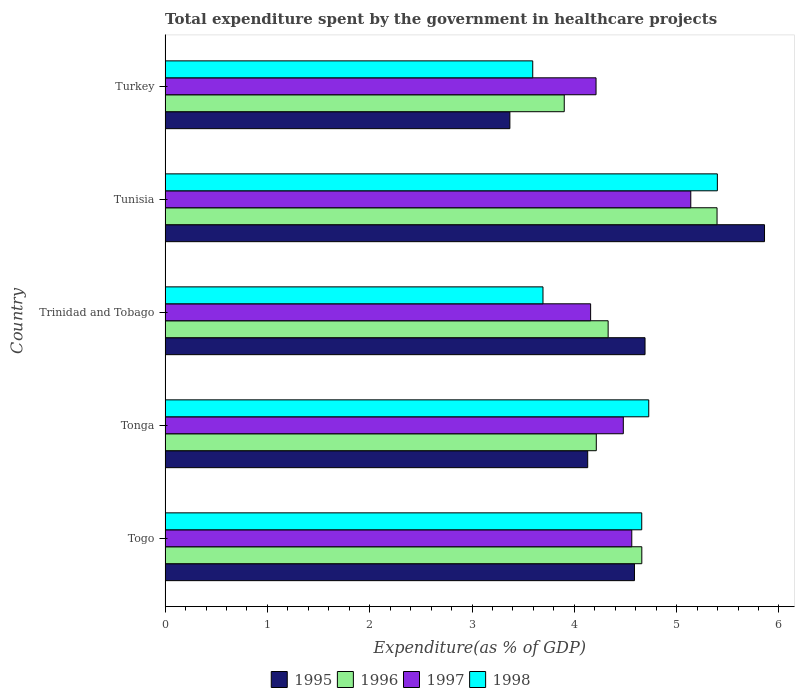How many groups of bars are there?
Your answer should be very brief. 5. Are the number of bars per tick equal to the number of legend labels?
Your answer should be very brief. Yes. What is the label of the 4th group of bars from the top?
Provide a short and direct response. Tonga. In how many cases, is the number of bars for a given country not equal to the number of legend labels?
Offer a terse response. 0. What is the total expenditure spent by the government in healthcare projects in 1996 in Tonga?
Make the answer very short. 4.21. Across all countries, what is the maximum total expenditure spent by the government in healthcare projects in 1995?
Offer a very short reply. 5.86. Across all countries, what is the minimum total expenditure spent by the government in healthcare projects in 1998?
Give a very brief answer. 3.59. In which country was the total expenditure spent by the government in healthcare projects in 1998 maximum?
Give a very brief answer. Tunisia. What is the total total expenditure spent by the government in healthcare projects in 1998 in the graph?
Provide a succinct answer. 22.07. What is the difference between the total expenditure spent by the government in healthcare projects in 1998 in Togo and that in Turkey?
Keep it short and to the point. 1.07. What is the difference between the total expenditure spent by the government in healthcare projects in 1995 in Tunisia and the total expenditure spent by the government in healthcare projects in 1998 in Trinidad and Tobago?
Keep it short and to the point. 2.17. What is the average total expenditure spent by the government in healthcare projects in 1995 per country?
Provide a succinct answer. 4.53. What is the difference between the total expenditure spent by the government in healthcare projects in 1996 and total expenditure spent by the government in healthcare projects in 1998 in Trinidad and Tobago?
Keep it short and to the point. 0.64. What is the ratio of the total expenditure spent by the government in healthcare projects in 1997 in Tonga to that in Turkey?
Your answer should be compact. 1.06. What is the difference between the highest and the second highest total expenditure spent by the government in healthcare projects in 1995?
Give a very brief answer. 1.17. What is the difference between the highest and the lowest total expenditure spent by the government in healthcare projects in 1997?
Offer a very short reply. 0.98. Is the sum of the total expenditure spent by the government in healthcare projects in 1995 in Tonga and Turkey greater than the maximum total expenditure spent by the government in healthcare projects in 1997 across all countries?
Provide a succinct answer. Yes. Is it the case that in every country, the sum of the total expenditure spent by the government in healthcare projects in 1998 and total expenditure spent by the government in healthcare projects in 1996 is greater than the sum of total expenditure spent by the government in healthcare projects in 1995 and total expenditure spent by the government in healthcare projects in 1997?
Offer a terse response. No. What does the 1st bar from the top in Togo represents?
Your response must be concise. 1998. Is it the case that in every country, the sum of the total expenditure spent by the government in healthcare projects in 1997 and total expenditure spent by the government in healthcare projects in 1996 is greater than the total expenditure spent by the government in healthcare projects in 1995?
Ensure brevity in your answer.  Yes. How many bars are there?
Offer a terse response. 20. Are all the bars in the graph horizontal?
Your response must be concise. Yes. Where does the legend appear in the graph?
Provide a short and direct response. Bottom center. How many legend labels are there?
Your response must be concise. 4. What is the title of the graph?
Your answer should be very brief. Total expenditure spent by the government in healthcare projects. Does "2003" appear as one of the legend labels in the graph?
Provide a short and direct response. No. What is the label or title of the X-axis?
Offer a terse response. Expenditure(as % of GDP). What is the label or title of the Y-axis?
Your answer should be very brief. Country. What is the Expenditure(as % of GDP) in 1995 in Togo?
Keep it short and to the point. 4.59. What is the Expenditure(as % of GDP) in 1996 in Togo?
Provide a short and direct response. 4.66. What is the Expenditure(as % of GDP) of 1997 in Togo?
Your answer should be very brief. 4.56. What is the Expenditure(as % of GDP) of 1998 in Togo?
Offer a terse response. 4.66. What is the Expenditure(as % of GDP) in 1995 in Tonga?
Ensure brevity in your answer.  4.13. What is the Expenditure(as % of GDP) in 1996 in Tonga?
Make the answer very short. 4.21. What is the Expenditure(as % of GDP) in 1997 in Tonga?
Provide a succinct answer. 4.48. What is the Expenditure(as % of GDP) of 1998 in Tonga?
Make the answer very short. 4.73. What is the Expenditure(as % of GDP) in 1995 in Trinidad and Tobago?
Give a very brief answer. 4.69. What is the Expenditure(as % of GDP) of 1996 in Trinidad and Tobago?
Offer a terse response. 4.33. What is the Expenditure(as % of GDP) of 1997 in Trinidad and Tobago?
Your response must be concise. 4.16. What is the Expenditure(as % of GDP) of 1998 in Trinidad and Tobago?
Make the answer very short. 3.69. What is the Expenditure(as % of GDP) of 1995 in Tunisia?
Keep it short and to the point. 5.86. What is the Expenditure(as % of GDP) in 1996 in Tunisia?
Offer a terse response. 5.4. What is the Expenditure(as % of GDP) of 1997 in Tunisia?
Offer a terse response. 5.14. What is the Expenditure(as % of GDP) in 1998 in Tunisia?
Provide a short and direct response. 5.4. What is the Expenditure(as % of GDP) of 1995 in Turkey?
Make the answer very short. 3.37. What is the Expenditure(as % of GDP) in 1996 in Turkey?
Your answer should be very brief. 3.9. What is the Expenditure(as % of GDP) in 1997 in Turkey?
Ensure brevity in your answer.  4.21. What is the Expenditure(as % of GDP) of 1998 in Turkey?
Provide a short and direct response. 3.59. Across all countries, what is the maximum Expenditure(as % of GDP) in 1995?
Your answer should be compact. 5.86. Across all countries, what is the maximum Expenditure(as % of GDP) of 1996?
Provide a short and direct response. 5.4. Across all countries, what is the maximum Expenditure(as % of GDP) in 1997?
Offer a terse response. 5.14. Across all countries, what is the maximum Expenditure(as % of GDP) in 1998?
Provide a succinct answer. 5.4. Across all countries, what is the minimum Expenditure(as % of GDP) of 1995?
Offer a terse response. 3.37. Across all countries, what is the minimum Expenditure(as % of GDP) of 1996?
Provide a succinct answer. 3.9. Across all countries, what is the minimum Expenditure(as % of GDP) in 1997?
Provide a succinct answer. 4.16. Across all countries, what is the minimum Expenditure(as % of GDP) of 1998?
Provide a succinct answer. 3.59. What is the total Expenditure(as % of GDP) in 1995 in the graph?
Your answer should be compact. 22.64. What is the total Expenditure(as % of GDP) of 1996 in the graph?
Your answer should be very brief. 22.5. What is the total Expenditure(as % of GDP) of 1997 in the graph?
Your answer should be very brief. 22.55. What is the total Expenditure(as % of GDP) of 1998 in the graph?
Your response must be concise. 22.07. What is the difference between the Expenditure(as % of GDP) of 1995 in Togo and that in Tonga?
Offer a very short reply. 0.46. What is the difference between the Expenditure(as % of GDP) in 1996 in Togo and that in Tonga?
Make the answer very short. 0.44. What is the difference between the Expenditure(as % of GDP) of 1997 in Togo and that in Tonga?
Ensure brevity in your answer.  0.08. What is the difference between the Expenditure(as % of GDP) of 1998 in Togo and that in Tonga?
Keep it short and to the point. -0.07. What is the difference between the Expenditure(as % of GDP) of 1995 in Togo and that in Trinidad and Tobago?
Offer a terse response. -0.1. What is the difference between the Expenditure(as % of GDP) of 1996 in Togo and that in Trinidad and Tobago?
Your answer should be very brief. 0.33. What is the difference between the Expenditure(as % of GDP) in 1997 in Togo and that in Trinidad and Tobago?
Your response must be concise. 0.4. What is the difference between the Expenditure(as % of GDP) of 1998 in Togo and that in Trinidad and Tobago?
Offer a very short reply. 0.97. What is the difference between the Expenditure(as % of GDP) of 1995 in Togo and that in Tunisia?
Offer a very short reply. -1.27. What is the difference between the Expenditure(as % of GDP) of 1996 in Togo and that in Tunisia?
Your answer should be compact. -0.74. What is the difference between the Expenditure(as % of GDP) of 1997 in Togo and that in Tunisia?
Make the answer very short. -0.58. What is the difference between the Expenditure(as % of GDP) in 1998 in Togo and that in Tunisia?
Your answer should be very brief. -0.74. What is the difference between the Expenditure(as % of GDP) of 1995 in Togo and that in Turkey?
Give a very brief answer. 1.22. What is the difference between the Expenditure(as % of GDP) of 1996 in Togo and that in Turkey?
Make the answer very short. 0.76. What is the difference between the Expenditure(as % of GDP) of 1997 in Togo and that in Turkey?
Provide a succinct answer. 0.35. What is the difference between the Expenditure(as % of GDP) of 1998 in Togo and that in Turkey?
Give a very brief answer. 1.07. What is the difference between the Expenditure(as % of GDP) of 1995 in Tonga and that in Trinidad and Tobago?
Offer a very short reply. -0.56. What is the difference between the Expenditure(as % of GDP) in 1996 in Tonga and that in Trinidad and Tobago?
Your response must be concise. -0.12. What is the difference between the Expenditure(as % of GDP) in 1997 in Tonga and that in Trinidad and Tobago?
Provide a succinct answer. 0.32. What is the difference between the Expenditure(as % of GDP) in 1998 in Tonga and that in Trinidad and Tobago?
Offer a terse response. 1.03. What is the difference between the Expenditure(as % of GDP) of 1995 in Tonga and that in Tunisia?
Your answer should be very brief. -1.73. What is the difference between the Expenditure(as % of GDP) in 1996 in Tonga and that in Tunisia?
Keep it short and to the point. -1.18. What is the difference between the Expenditure(as % of GDP) in 1997 in Tonga and that in Tunisia?
Your response must be concise. -0.66. What is the difference between the Expenditure(as % of GDP) of 1998 in Tonga and that in Tunisia?
Make the answer very short. -0.67. What is the difference between the Expenditure(as % of GDP) of 1995 in Tonga and that in Turkey?
Give a very brief answer. 0.76. What is the difference between the Expenditure(as % of GDP) of 1996 in Tonga and that in Turkey?
Ensure brevity in your answer.  0.31. What is the difference between the Expenditure(as % of GDP) in 1997 in Tonga and that in Turkey?
Your answer should be compact. 0.27. What is the difference between the Expenditure(as % of GDP) of 1998 in Tonga and that in Turkey?
Keep it short and to the point. 1.13. What is the difference between the Expenditure(as % of GDP) of 1995 in Trinidad and Tobago and that in Tunisia?
Your answer should be very brief. -1.17. What is the difference between the Expenditure(as % of GDP) in 1996 in Trinidad and Tobago and that in Tunisia?
Offer a terse response. -1.06. What is the difference between the Expenditure(as % of GDP) in 1997 in Trinidad and Tobago and that in Tunisia?
Provide a short and direct response. -0.98. What is the difference between the Expenditure(as % of GDP) of 1998 in Trinidad and Tobago and that in Tunisia?
Provide a short and direct response. -1.7. What is the difference between the Expenditure(as % of GDP) in 1995 in Trinidad and Tobago and that in Turkey?
Give a very brief answer. 1.32. What is the difference between the Expenditure(as % of GDP) in 1996 in Trinidad and Tobago and that in Turkey?
Offer a very short reply. 0.43. What is the difference between the Expenditure(as % of GDP) of 1997 in Trinidad and Tobago and that in Turkey?
Give a very brief answer. -0.05. What is the difference between the Expenditure(as % of GDP) in 1998 in Trinidad and Tobago and that in Turkey?
Provide a short and direct response. 0.1. What is the difference between the Expenditure(as % of GDP) in 1995 in Tunisia and that in Turkey?
Your answer should be very brief. 2.49. What is the difference between the Expenditure(as % of GDP) in 1996 in Tunisia and that in Turkey?
Ensure brevity in your answer.  1.49. What is the difference between the Expenditure(as % of GDP) in 1997 in Tunisia and that in Turkey?
Give a very brief answer. 0.93. What is the difference between the Expenditure(as % of GDP) of 1998 in Tunisia and that in Turkey?
Provide a short and direct response. 1.8. What is the difference between the Expenditure(as % of GDP) in 1995 in Togo and the Expenditure(as % of GDP) in 1996 in Tonga?
Your response must be concise. 0.37. What is the difference between the Expenditure(as % of GDP) in 1995 in Togo and the Expenditure(as % of GDP) in 1997 in Tonga?
Ensure brevity in your answer.  0.11. What is the difference between the Expenditure(as % of GDP) of 1995 in Togo and the Expenditure(as % of GDP) of 1998 in Tonga?
Your answer should be compact. -0.14. What is the difference between the Expenditure(as % of GDP) of 1996 in Togo and the Expenditure(as % of GDP) of 1997 in Tonga?
Keep it short and to the point. 0.18. What is the difference between the Expenditure(as % of GDP) of 1996 in Togo and the Expenditure(as % of GDP) of 1998 in Tonga?
Keep it short and to the point. -0.07. What is the difference between the Expenditure(as % of GDP) in 1997 in Togo and the Expenditure(as % of GDP) in 1998 in Tonga?
Offer a very short reply. -0.17. What is the difference between the Expenditure(as % of GDP) of 1995 in Togo and the Expenditure(as % of GDP) of 1996 in Trinidad and Tobago?
Your answer should be very brief. 0.26. What is the difference between the Expenditure(as % of GDP) in 1995 in Togo and the Expenditure(as % of GDP) in 1997 in Trinidad and Tobago?
Your answer should be very brief. 0.43. What is the difference between the Expenditure(as % of GDP) of 1995 in Togo and the Expenditure(as % of GDP) of 1998 in Trinidad and Tobago?
Your answer should be very brief. 0.89. What is the difference between the Expenditure(as % of GDP) in 1996 in Togo and the Expenditure(as % of GDP) in 1997 in Trinidad and Tobago?
Provide a short and direct response. 0.5. What is the difference between the Expenditure(as % of GDP) in 1997 in Togo and the Expenditure(as % of GDP) in 1998 in Trinidad and Tobago?
Provide a succinct answer. 0.87. What is the difference between the Expenditure(as % of GDP) in 1995 in Togo and the Expenditure(as % of GDP) in 1996 in Tunisia?
Make the answer very short. -0.81. What is the difference between the Expenditure(as % of GDP) in 1995 in Togo and the Expenditure(as % of GDP) in 1997 in Tunisia?
Provide a short and direct response. -0.55. What is the difference between the Expenditure(as % of GDP) in 1995 in Togo and the Expenditure(as % of GDP) in 1998 in Tunisia?
Your answer should be compact. -0.81. What is the difference between the Expenditure(as % of GDP) in 1996 in Togo and the Expenditure(as % of GDP) in 1997 in Tunisia?
Your answer should be compact. -0.48. What is the difference between the Expenditure(as % of GDP) in 1996 in Togo and the Expenditure(as % of GDP) in 1998 in Tunisia?
Your answer should be very brief. -0.74. What is the difference between the Expenditure(as % of GDP) in 1997 in Togo and the Expenditure(as % of GDP) in 1998 in Tunisia?
Provide a succinct answer. -0.84. What is the difference between the Expenditure(as % of GDP) of 1995 in Togo and the Expenditure(as % of GDP) of 1996 in Turkey?
Keep it short and to the point. 0.69. What is the difference between the Expenditure(as % of GDP) of 1995 in Togo and the Expenditure(as % of GDP) of 1997 in Turkey?
Offer a terse response. 0.38. What is the difference between the Expenditure(as % of GDP) in 1996 in Togo and the Expenditure(as % of GDP) in 1997 in Turkey?
Offer a very short reply. 0.45. What is the difference between the Expenditure(as % of GDP) in 1996 in Togo and the Expenditure(as % of GDP) in 1998 in Turkey?
Provide a succinct answer. 1.07. What is the difference between the Expenditure(as % of GDP) of 1997 in Togo and the Expenditure(as % of GDP) of 1998 in Turkey?
Your answer should be compact. 0.97. What is the difference between the Expenditure(as % of GDP) in 1995 in Tonga and the Expenditure(as % of GDP) in 1996 in Trinidad and Tobago?
Make the answer very short. -0.2. What is the difference between the Expenditure(as % of GDP) in 1995 in Tonga and the Expenditure(as % of GDP) in 1997 in Trinidad and Tobago?
Provide a succinct answer. -0.03. What is the difference between the Expenditure(as % of GDP) of 1995 in Tonga and the Expenditure(as % of GDP) of 1998 in Trinidad and Tobago?
Keep it short and to the point. 0.44. What is the difference between the Expenditure(as % of GDP) in 1996 in Tonga and the Expenditure(as % of GDP) in 1997 in Trinidad and Tobago?
Offer a terse response. 0.06. What is the difference between the Expenditure(as % of GDP) in 1996 in Tonga and the Expenditure(as % of GDP) in 1998 in Trinidad and Tobago?
Give a very brief answer. 0.52. What is the difference between the Expenditure(as % of GDP) in 1997 in Tonga and the Expenditure(as % of GDP) in 1998 in Trinidad and Tobago?
Make the answer very short. 0.79. What is the difference between the Expenditure(as % of GDP) in 1995 in Tonga and the Expenditure(as % of GDP) in 1996 in Tunisia?
Offer a very short reply. -1.26. What is the difference between the Expenditure(as % of GDP) of 1995 in Tonga and the Expenditure(as % of GDP) of 1997 in Tunisia?
Offer a very short reply. -1.01. What is the difference between the Expenditure(as % of GDP) of 1995 in Tonga and the Expenditure(as % of GDP) of 1998 in Tunisia?
Ensure brevity in your answer.  -1.27. What is the difference between the Expenditure(as % of GDP) of 1996 in Tonga and the Expenditure(as % of GDP) of 1997 in Tunisia?
Offer a terse response. -0.92. What is the difference between the Expenditure(as % of GDP) in 1996 in Tonga and the Expenditure(as % of GDP) in 1998 in Tunisia?
Your answer should be compact. -1.18. What is the difference between the Expenditure(as % of GDP) of 1997 in Tonga and the Expenditure(as % of GDP) of 1998 in Tunisia?
Your response must be concise. -0.92. What is the difference between the Expenditure(as % of GDP) in 1995 in Tonga and the Expenditure(as % of GDP) in 1996 in Turkey?
Keep it short and to the point. 0.23. What is the difference between the Expenditure(as % of GDP) of 1995 in Tonga and the Expenditure(as % of GDP) of 1997 in Turkey?
Offer a very short reply. -0.08. What is the difference between the Expenditure(as % of GDP) in 1995 in Tonga and the Expenditure(as % of GDP) in 1998 in Turkey?
Give a very brief answer. 0.54. What is the difference between the Expenditure(as % of GDP) in 1996 in Tonga and the Expenditure(as % of GDP) in 1997 in Turkey?
Keep it short and to the point. 0. What is the difference between the Expenditure(as % of GDP) of 1996 in Tonga and the Expenditure(as % of GDP) of 1998 in Turkey?
Make the answer very short. 0.62. What is the difference between the Expenditure(as % of GDP) in 1997 in Tonga and the Expenditure(as % of GDP) in 1998 in Turkey?
Give a very brief answer. 0.89. What is the difference between the Expenditure(as % of GDP) of 1995 in Trinidad and Tobago and the Expenditure(as % of GDP) of 1996 in Tunisia?
Your response must be concise. -0.7. What is the difference between the Expenditure(as % of GDP) in 1995 in Trinidad and Tobago and the Expenditure(as % of GDP) in 1997 in Tunisia?
Ensure brevity in your answer.  -0.45. What is the difference between the Expenditure(as % of GDP) of 1995 in Trinidad and Tobago and the Expenditure(as % of GDP) of 1998 in Tunisia?
Your answer should be compact. -0.71. What is the difference between the Expenditure(as % of GDP) of 1996 in Trinidad and Tobago and the Expenditure(as % of GDP) of 1997 in Tunisia?
Make the answer very short. -0.81. What is the difference between the Expenditure(as % of GDP) of 1996 in Trinidad and Tobago and the Expenditure(as % of GDP) of 1998 in Tunisia?
Make the answer very short. -1.07. What is the difference between the Expenditure(as % of GDP) of 1997 in Trinidad and Tobago and the Expenditure(as % of GDP) of 1998 in Tunisia?
Your answer should be compact. -1.24. What is the difference between the Expenditure(as % of GDP) of 1995 in Trinidad and Tobago and the Expenditure(as % of GDP) of 1996 in Turkey?
Provide a succinct answer. 0.79. What is the difference between the Expenditure(as % of GDP) in 1995 in Trinidad and Tobago and the Expenditure(as % of GDP) in 1997 in Turkey?
Keep it short and to the point. 0.48. What is the difference between the Expenditure(as % of GDP) of 1995 in Trinidad and Tobago and the Expenditure(as % of GDP) of 1998 in Turkey?
Provide a short and direct response. 1.1. What is the difference between the Expenditure(as % of GDP) of 1996 in Trinidad and Tobago and the Expenditure(as % of GDP) of 1997 in Turkey?
Provide a short and direct response. 0.12. What is the difference between the Expenditure(as % of GDP) of 1996 in Trinidad and Tobago and the Expenditure(as % of GDP) of 1998 in Turkey?
Ensure brevity in your answer.  0.74. What is the difference between the Expenditure(as % of GDP) in 1997 in Trinidad and Tobago and the Expenditure(as % of GDP) in 1998 in Turkey?
Offer a very short reply. 0.57. What is the difference between the Expenditure(as % of GDP) in 1995 in Tunisia and the Expenditure(as % of GDP) in 1996 in Turkey?
Your response must be concise. 1.96. What is the difference between the Expenditure(as % of GDP) in 1995 in Tunisia and the Expenditure(as % of GDP) in 1997 in Turkey?
Make the answer very short. 1.65. What is the difference between the Expenditure(as % of GDP) of 1995 in Tunisia and the Expenditure(as % of GDP) of 1998 in Turkey?
Your response must be concise. 2.27. What is the difference between the Expenditure(as % of GDP) in 1996 in Tunisia and the Expenditure(as % of GDP) in 1997 in Turkey?
Your response must be concise. 1.18. What is the difference between the Expenditure(as % of GDP) of 1996 in Tunisia and the Expenditure(as % of GDP) of 1998 in Turkey?
Offer a very short reply. 1.8. What is the difference between the Expenditure(as % of GDP) in 1997 in Tunisia and the Expenditure(as % of GDP) in 1998 in Turkey?
Your answer should be very brief. 1.54. What is the average Expenditure(as % of GDP) of 1995 per country?
Make the answer very short. 4.53. What is the average Expenditure(as % of GDP) in 1996 per country?
Your response must be concise. 4.5. What is the average Expenditure(as % of GDP) in 1997 per country?
Provide a short and direct response. 4.51. What is the average Expenditure(as % of GDP) in 1998 per country?
Provide a succinct answer. 4.41. What is the difference between the Expenditure(as % of GDP) of 1995 and Expenditure(as % of GDP) of 1996 in Togo?
Keep it short and to the point. -0.07. What is the difference between the Expenditure(as % of GDP) of 1995 and Expenditure(as % of GDP) of 1997 in Togo?
Offer a very short reply. 0.03. What is the difference between the Expenditure(as % of GDP) of 1995 and Expenditure(as % of GDP) of 1998 in Togo?
Provide a short and direct response. -0.07. What is the difference between the Expenditure(as % of GDP) of 1996 and Expenditure(as % of GDP) of 1997 in Togo?
Provide a short and direct response. 0.1. What is the difference between the Expenditure(as % of GDP) of 1996 and Expenditure(as % of GDP) of 1998 in Togo?
Ensure brevity in your answer.  0. What is the difference between the Expenditure(as % of GDP) in 1997 and Expenditure(as % of GDP) in 1998 in Togo?
Your answer should be very brief. -0.1. What is the difference between the Expenditure(as % of GDP) in 1995 and Expenditure(as % of GDP) in 1996 in Tonga?
Ensure brevity in your answer.  -0.08. What is the difference between the Expenditure(as % of GDP) in 1995 and Expenditure(as % of GDP) in 1997 in Tonga?
Make the answer very short. -0.35. What is the difference between the Expenditure(as % of GDP) of 1995 and Expenditure(as % of GDP) of 1998 in Tonga?
Your response must be concise. -0.6. What is the difference between the Expenditure(as % of GDP) in 1996 and Expenditure(as % of GDP) in 1997 in Tonga?
Your response must be concise. -0.26. What is the difference between the Expenditure(as % of GDP) of 1996 and Expenditure(as % of GDP) of 1998 in Tonga?
Provide a short and direct response. -0.51. What is the difference between the Expenditure(as % of GDP) of 1997 and Expenditure(as % of GDP) of 1998 in Tonga?
Your answer should be very brief. -0.25. What is the difference between the Expenditure(as % of GDP) in 1995 and Expenditure(as % of GDP) in 1996 in Trinidad and Tobago?
Provide a succinct answer. 0.36. What is the difference between the Expenditure(as % of GDP) in 1995 and Expenditure(as % of GDP) in 1997 in Trinidad and Tobago?
Your answer should be compact. 0.53. What is the difference between the Expenditure(as % of GDP) of 1996 and Expenditure(as % of GDP) of 1997 in Trinidad and Tobago?
Provide a short and direct response. 0.17. What is the difference between the Expenditure(as % of GDP) in 1996 and Expenditure(as % of GDP) in 1998 in Trinidad and Tobago?
Your answer should be compact. 0.64. What is the difference between the Expenditure(as % of GDP) in 1997 and Expenditure(as % of GDP) in 1998 in Trinidad and Tobago?
Offer a very short reply. 0.47. What is the difference between the Expenditure(as % of GDP) of 1995 and Expenditure(as % of GDP) of 1996 in Tunisia?
Provide a short and direct response. 0.46. What is the difference between the Expenditure(as % of GDP) of 1995 and Expenditure(as % of GDP) of 1997 in Tunisia?
Your answer should be very brief. 0.72. What is the difference between the Expenditure(as % of GDP) in 1995 and Expenditure(as % of GDP) in 1998 in Tunisia?
Provide a short and direct response. 0.46. What is the difference between the Expenditure(as % of GDP) in 1996 and Expenditure(as % of GDP) in 1997 in Tunisia?
Give a very brief answer. 0.26. What is the difference between the Expenditure(as % of GDP) in 1996 and Expenditure(as % of GDP) in 1998 in Tunisia?
Keep it short and to the point. -0. What is the difference between the Expenditure(as % of GDP) of 1997 and Expenditure(as % of GDP) of 1998 in Tunisia?
Keep it short and to the point. -0.26. What is the difference between the Expenditure(as % of GDP) in 1995 and Expenditure(as % of GDP) in 1996 in Turkey?
Ensure brevity in your answer.  -0.53. What is the difference between the Expenditure(as % of GDP) of 1995 and Expenditure(as % of GDP) of 1997 in Turkey?
Your answer should be very brief. -0.84. What is the difference between the Expenditure(as % of GDP) of 1995 and Expenditure(as % of GDP) of 1998 in Turkey?
Provide a succinct answer. -0.22. What is the difference between the Expenditure(as % of GDP) of 1996 and Expenditure(as % of GDP) of 1997 in Turkey?
Your response must be concise. -0.31. What is the difference between the Expenditure(as % of GDP) in 1996 and Expenditure(as % of GDP) in 1998 in Turkey?
Provide a short and direct response. 0.31. What is the difference between the Expenditure(as % of GDP) of 1997 and Expenditure(as % of GDP) of 1998 in Turkey?
Provide a short and direct response. 0.62. What is the ratio of the Expenditure(as % of GDP) in 1995 in Togo to that in Tonga?
Offer a very short reply. 1.11. What is the ratio of the Expenditure(as % of GDP) of 1996 in Togo to that in Tonga?
Offer a very short reply. 1.11. What is the ratio of the Expenditure(as % of GDP) of 1997 in Togo to that in Tonga?
Your response must be concise. 1.02. What is the ratio of the Expenditure(as % of GDP) in 1998 in Togo to that in Tonga?
Your answer should be very brief. 0.99. What is the ratio of the Expenditure(as % of GDP) in 1995 in Togo to that in Trinidad and Tobago?
Your answer should be very brief. 0.98. What is the ratio of the Expenditure(as % of GDP) in 1996 in Togo to that in Trinidad and Tobago?
Make the answer very short. 1.08. What is the ratio of the Expenditure(as % of GDP) of 1997 in Togo to that in Trinidad and Tobago?
Make the answer very short. 1.1. What is the ratio of the Expenditure(as % of GDP) in 1998 in Togo to that in Trinidad and Tobago?
Provide a succinct answer. 1.26. What is the ratio of the Expenditure(as % of GDP) in 1995 in Togo to that in Tunisia?
Ensure brevity in your answer.  0.78. What is the ratio of the Expenditure(as % of GDP) of 1996 in Togo to that in Tunisia?
Keep it short and to the point. 0.86. What is the ratio of the Expenditure(as % of GDP) of 1997 in Togo to that in Tunisia?
Provide a short and direct response. 0.89. What is the ratio of the Expenditure(as % of GDP) in 1998 in Togo to that in Tunisia?
Keep it short and to the point. 0.86. What is the ratio of the Expenditure(as % of GDP) in 1995 in Togo to that in Turkey?
Your response must be concise. 1.36. What is the ratio of the Expenditure(as % of GDP) of 1996 in Togo to that in Turkey?
Offer a terse response. 1.19. What is the ratio of the Expenditure(as % of GDP) in 1997 in Togo to that in Turkey?
Your answer should be compact. 1.08. What is the ratio of the Expenditure(as % of GDP) in 1998 in Togo to that in Turkey?
Provide a short and direct response. 1.3. What is the ratio of the Expenditure(as % of GDP) of 1995 in Tonga to that in Trinidad and Tobago?
Make the answer very short. 0.88. What is the ratio of the Expenditure(as % of GDP) of 1996 in Tonga to that in Trinidad and Tobago?
Your answer should be very brief. 0.97. What is the ratio of the Expenditure(as % of GDP) of 1997 in Tonga to that in Trinidad and Tobago?
Make the answer very short. 1.08. What is the ratio of the Expenditure(as % of GDP) of 1998 in Tonga to that in Trinidad and Tobago?
Offer a very short reply. 1.28. What is the ratio of the Expenditure(as % of GDP) of 1995 in Tonga to that in Tunisia?
Provide a succinct answer. 0.7. What is the ratio of the Expenditure(as % of GDP) of 1996 in Tonga to that in Tunisia?
Your response must be concise. 0.78. What is the ratio of the Expenditure(as % of GDP) of 1997 in Tonga to that in Tunisia?
Provide a succinct answer. 0.87. What is the ratio of the Expenditure(as % of GDP) of 1998 in Tonga to that in Tunisia?
Your answer should be very brief. 0.88. What is the ratio of the Expenditure(as % of GDP) of 1995 in Tonga to that in Turkey?
Ensure brevity in your answer.  1.23. What is the ratio of the Expenditure(as % of GDP) of 1996 in Tonga to that in Turkey?
Your answer should be compact. 1.08. What is the ratio of the Expenditure(as % of GDP) of 1997 in Tonga to that in Turkey?
Your answer should be compact. 1.06. What is the ratio of the Expenditure(as % of GDP) in 1998 in Tonga to that in Turkey?
Keep it short and to the point. 1.32. What is the ratio of the Expenditure(as % of GDP) of 1995 in Trinidad and Tobago to that in Tunisia?
Your answer should be compact. 0.8. What is the ratio of the Expenditure(as % of GDP) in 1996 in Trinidad and Tobago to that in Tunisia?
Provide a short and direct response. 0.8. What is the ratio of the Expenditure(as % of GDP) in 1997 in Trinidad and Tobago to that in Tunisia?
Your answer should be compact. 0.81. What is the ratio of the Expenditure(as % of GDP) in 1998 in Trinidad and Tobago to that in Tunisia?
Ensure brevity in your answer.  0.68. What is the ratio of the Expenditure(as % of GDP) of 1995 in Trinidad and Tobago to that in Turkey?
Your answer should be very brief. 1.39. What is the ratio of the Expenditure(as % of GDP) of 1996 in Trinidad and Tobago to that in Turkey?
Offer a terse response. 1.11. What is the ratio of the Expenditure(as % of GDP) in 1997 in Trinidad and Tobago to that in Turkey?
Offer a terse response. 0.99. What is the ratio of the Expenditure(as % of GDP) of 1998 in Trinidad and Tobago to that in Turkey?
Make the answer very short. 1.03. What is the ratio of the Expenditure(as % of GDP) of 1995 in Tunisia to that in Turkey?
Your answer should be compact. 1.74. What is the ratio of the Expenditure(as % of GDP) in 1996 in Tunisia to that in Turkey?
Offer a very short reply. 1.38. What is the ratio of the Expenditure(as % of GDP) in 1997 in Tunisia to that in Turkey?
Make the answer very short. 1.22. What is the ratio of the Expenditure(as % of GDP) in 1998 in Tunisia to that in Turkey?
Your answer should be very brief. 1.5. What is the difference between the highest and the second highest Expenditure(as % of GDP) in 1995?
Make the answer very short. 1.17. What is the difference between the highest and the second highest Expenditure(as % of GDP) of 1996?
Ensure brevity in your answer.  0.74. What is the difference between the highest and the second highest Expenditure(as % of GDP) in 1997?
Make the answer very short. 0.58. What is the difference between the highest and the second highest Expenditure(as % of GDP) of 1998?
Ensure brevity in your answer.  0.67. What is the difference between the highest and the lowest Expenditure(as % of GDP) in 1995?
Offer a very short reply. 2.49. What is the difference between the highest and the lowest Expenditure(as % of GDP) of 1996?
Offer a very short reply. 1.49. What is the difference between the highest and the lowest Expenditure(as % of GDP) in 1998?
Your answer should be compact. 1.8. 